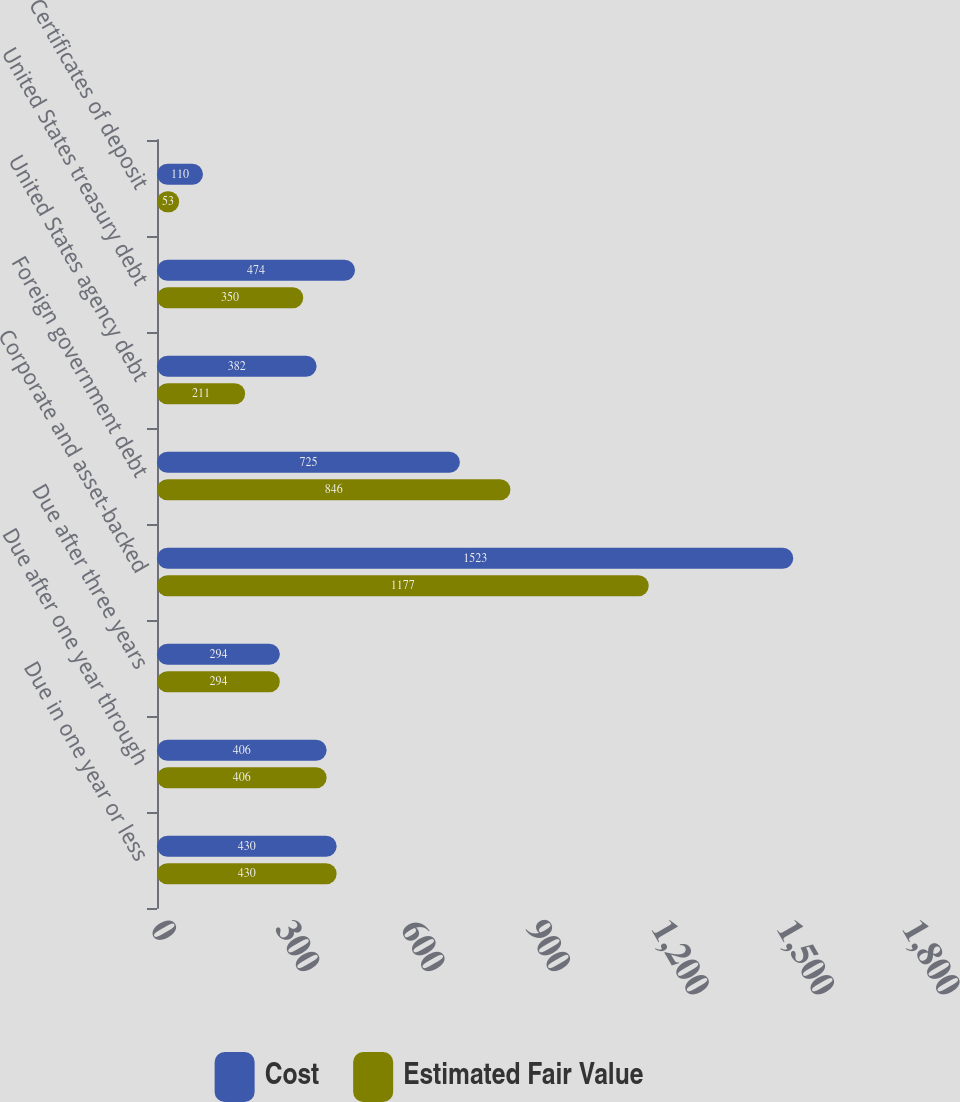Convert chart to OTSL. <chart><loc_0><loc_0><loc_500><loc_500><stacked_bar_chart><ecel><fcel>Due in one year or less<fcel>Due after one year through<fcel>Due after three years<fcel>Corporate and asset-backed<fcel>Foreign government debt<fcel>United States agency debt<fcel>United States treasury debt<fcel>Certificates of deposit<nl><fcel>Cost<fcel>430<fcel>406<fcel>294<fcel>1523<fcel>725<fcel>382<fcel>474<fcel>110<nl><fcel>Estimated Fair Value<fcel>430<fcel>406<fcel>294<fcel>1177<fcel>846<fcel>211<fcel>350<fcel>53<nl></chart> 